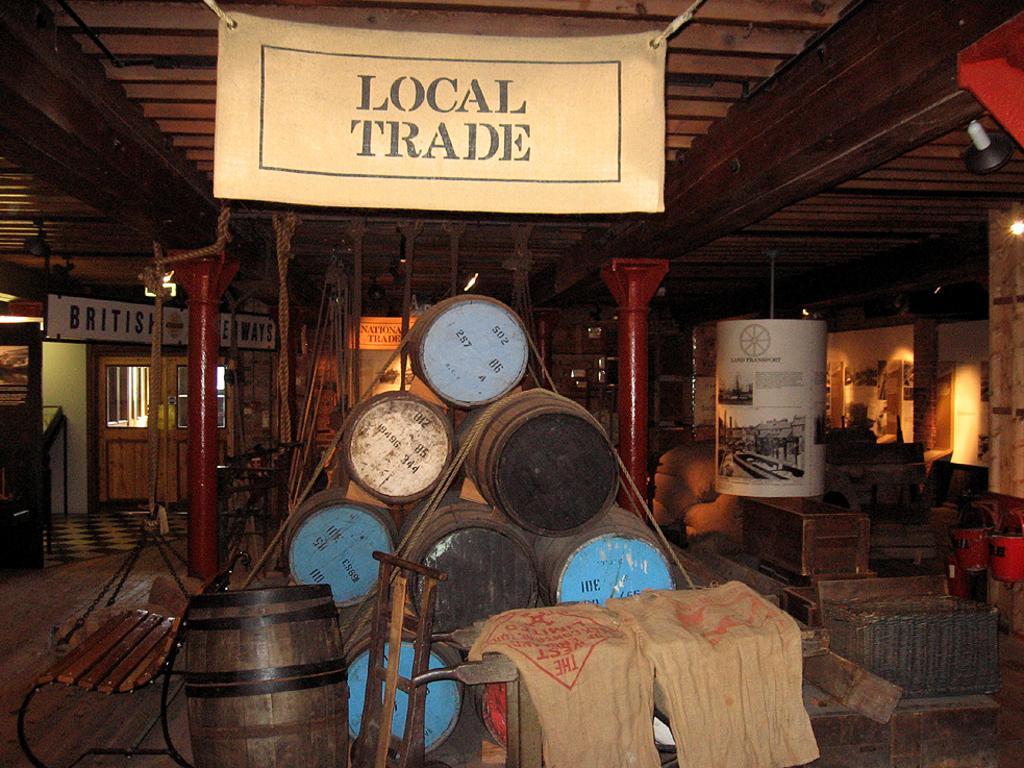How would you summarize this image in a sentence or two? In this image there is a shed, inside the shed there are drums, bags, bench and boxes, in the background there is a door, in the top there is hanging poster, on that it is written as local trade. 